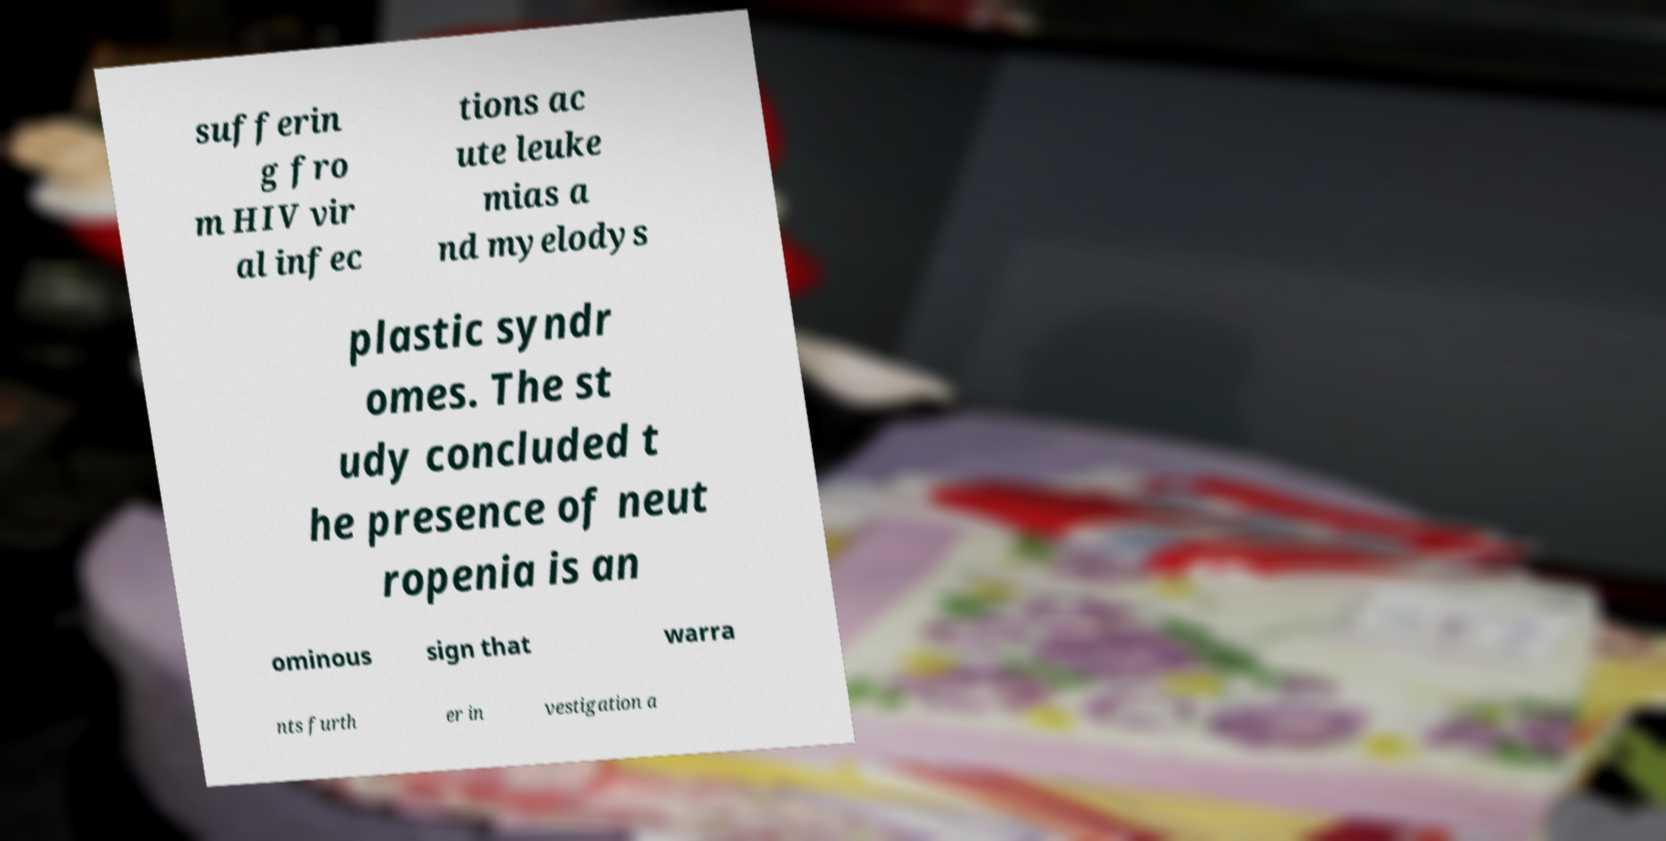There's text embedded in this image that I need extracted. Can you transcribe it verbatim? sufferin g fro m HIV vir al infec tions ac ute leuke mias a nd myelodys plastic syndr omes. The st udy concluded t he presence of neut ropenia is an ominous sign that warra nts furth er in vestigation a 